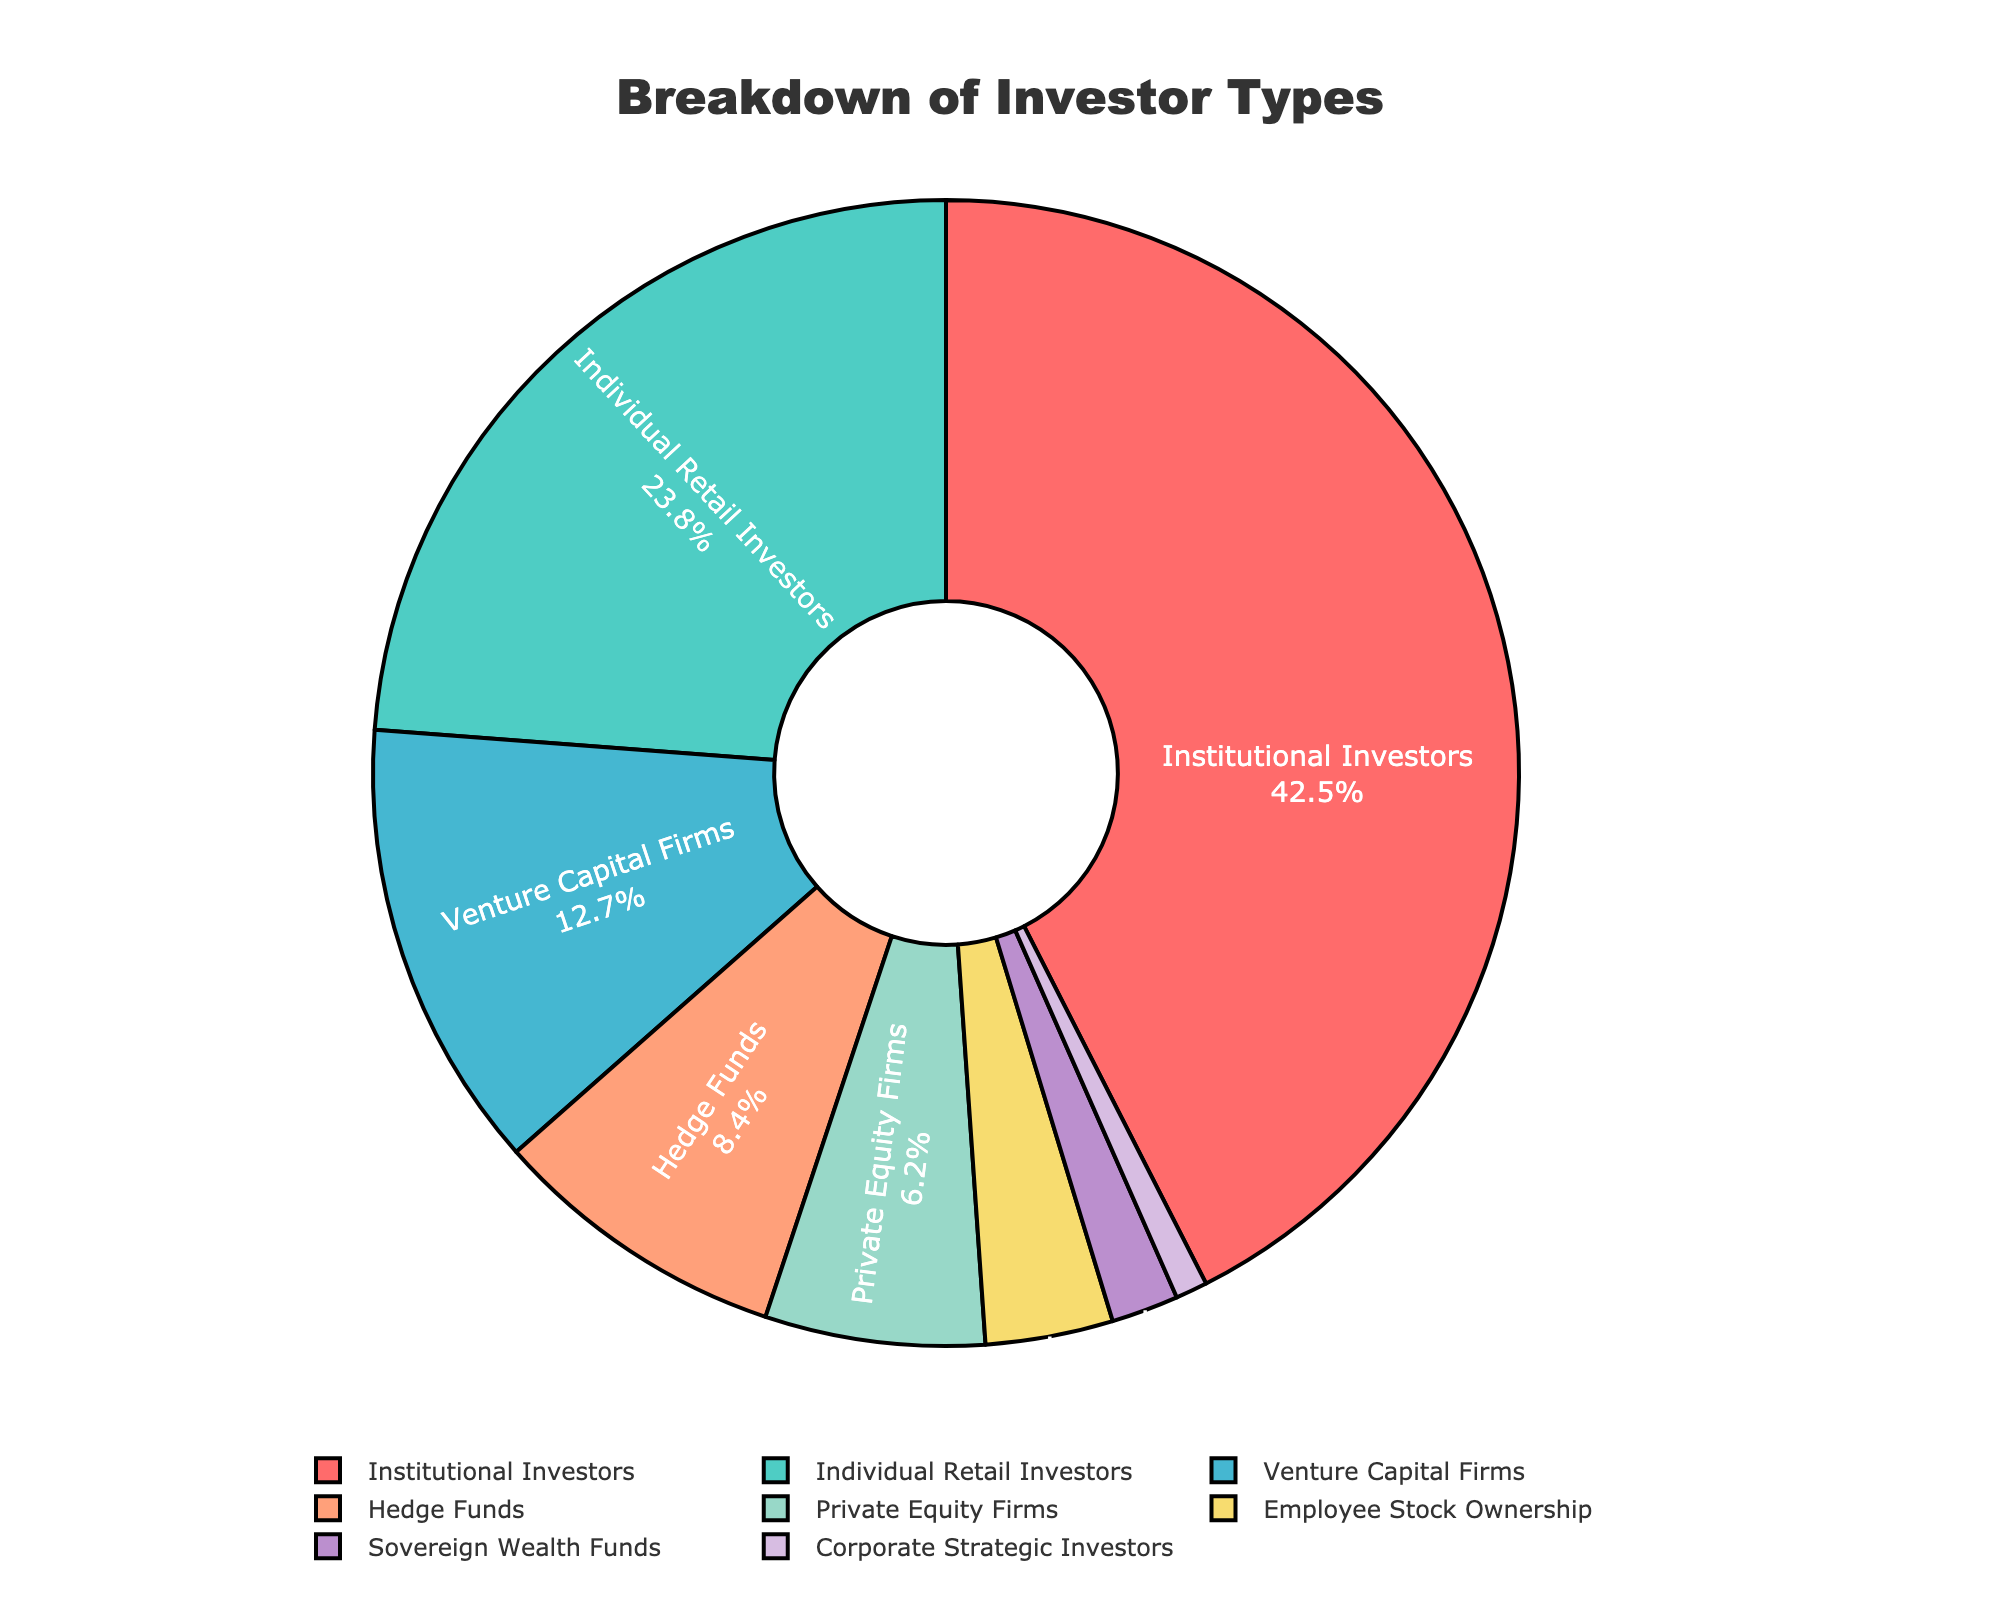What percentage of the company is owned by Institutional Investors and Venture Capital Firms combined? To find the combined percentage of company ownership by Institutional Investors and Venture Capital Firms, add their percentages: Institutional Investors (42.5%) + Venture Capital Firms (12.7%) = 55.2%.
Answer: 55.2% Which investor type holds a greater percentage of ownership, Hedge Funds or Private Equity Firms? Compare the percentage of ownership between Hedge Funds (8.4%) and Private Equity Firms (6.2%). Since 8.4% > 6.2%, Hedge Funds hold a greater percentage.
Answer: Hedge Funds Which two investor types have the smallest ownership percentages? Identify the two investor types with the lowest percentages: Sovereign Wealth Funds (1.9%) and Corporate Strategic Investors (0.9%).
Answer: Sovereign Wealth Funds and Corporate Strategic Investors What is the combined ownership percentage of Employee Stock Ownership, Sovereign Wealth Funds, and Corporate Strategic Investors? Sum the percentages: Employee Stock Ownership (3.6%) + Sovereign Wealth Funds (1.9%) + Corporate Strategic Investors (0.9%) = 6.4%.
Answer: 6.4% How much larger is the percentage of ownership of Institutional Investors compared to Individual Retail Investors? Subtract the percentage of Individual Retail Investors (23.8%) from Institutional Investors (42.5%): 42.5% - 23.8% = 18.7%.
Answer: 18.7% What is the second-largest investor type by percentage and what is its color in the pie chart? Identify the second-largest percentage after Institutional Investors (42.5%), which is Individual Retail Investors (23.8%). The color associated with Individual Retail Investors is green (based on the colors list provided).
Answer: Individual Retail Investors and green What is the average percentage of ownership for Hedge Funds, Private Equity Firms, and Employee Stock Ownership? Sum the percentages and divide by the number of categories: (8.4% + 6.2% + 3.6%) / 3 = 18.2% / 3 = 6.07%.
Answer: 6.07% Out of the listed investor types, which type has the smallest slice in the pie chart? Identify the investor type with the smallest percentage: Corporate Strategic Investors (0.9%).
Answer: Corporate Strategic Investors Which has a higher percentage, the combination of Hedge Funds and Private Equity Firms or Institutional Investors alone? Sum the percentages of Hedge Funds (8.4%) and Private Equity Firms (6.2%): 8.4% + 6.2% = 14.6%. Compare it with Institutional Investors (42.5%): 42.5% > 14.6%, so Institutional Investors alone have a higher percentage.
Answer: Institutional Investors alone 